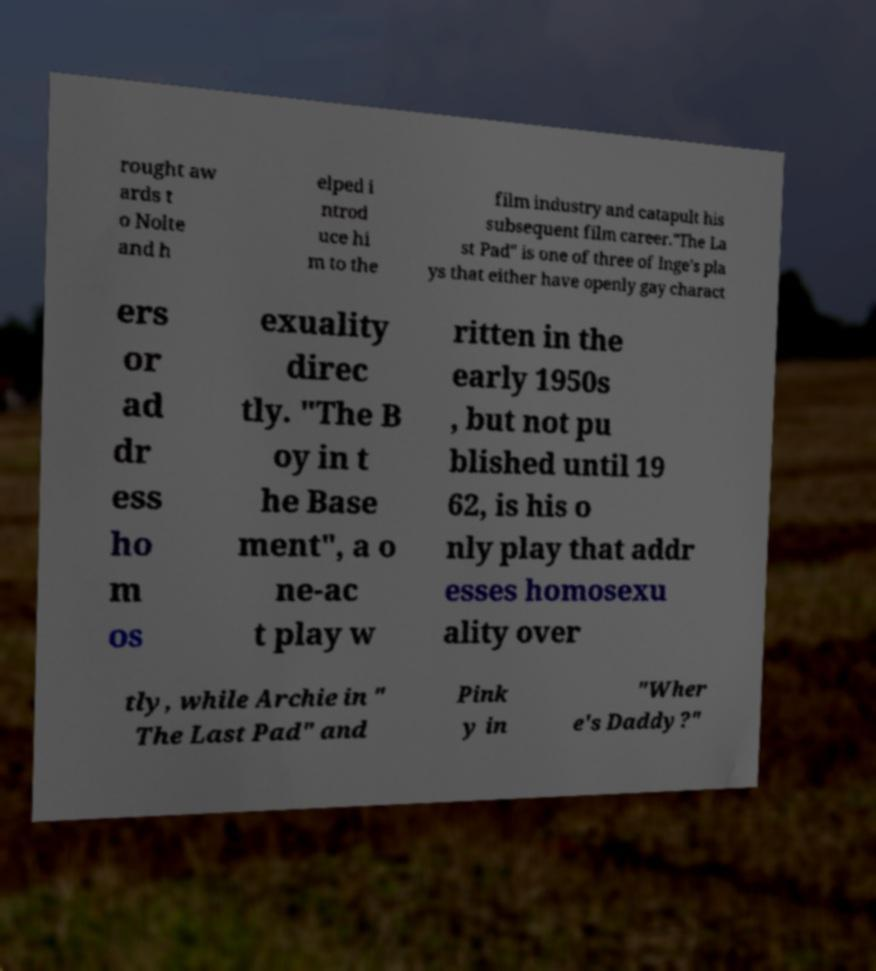Could you assist in decoding the text presented in this image and type it out clearly? rought aw ards t o Nolte and h elped i ntrod uce hi m to the film industry and catapult his subsequent film career."The La st Pad" is one of three of Inge's pla ys that either have openly gay charact ers or ad dr ess ho m os exuality direc tly. "The B oy in t he Base ment", a o ne-ac t play w ritten in the early 1950s , but not pu blished until 19 62, is his o nly play that addr esses homosexu ality over tly, while Archie in " The Last Pad" and Pink y in "Wher e's Daddy?" 